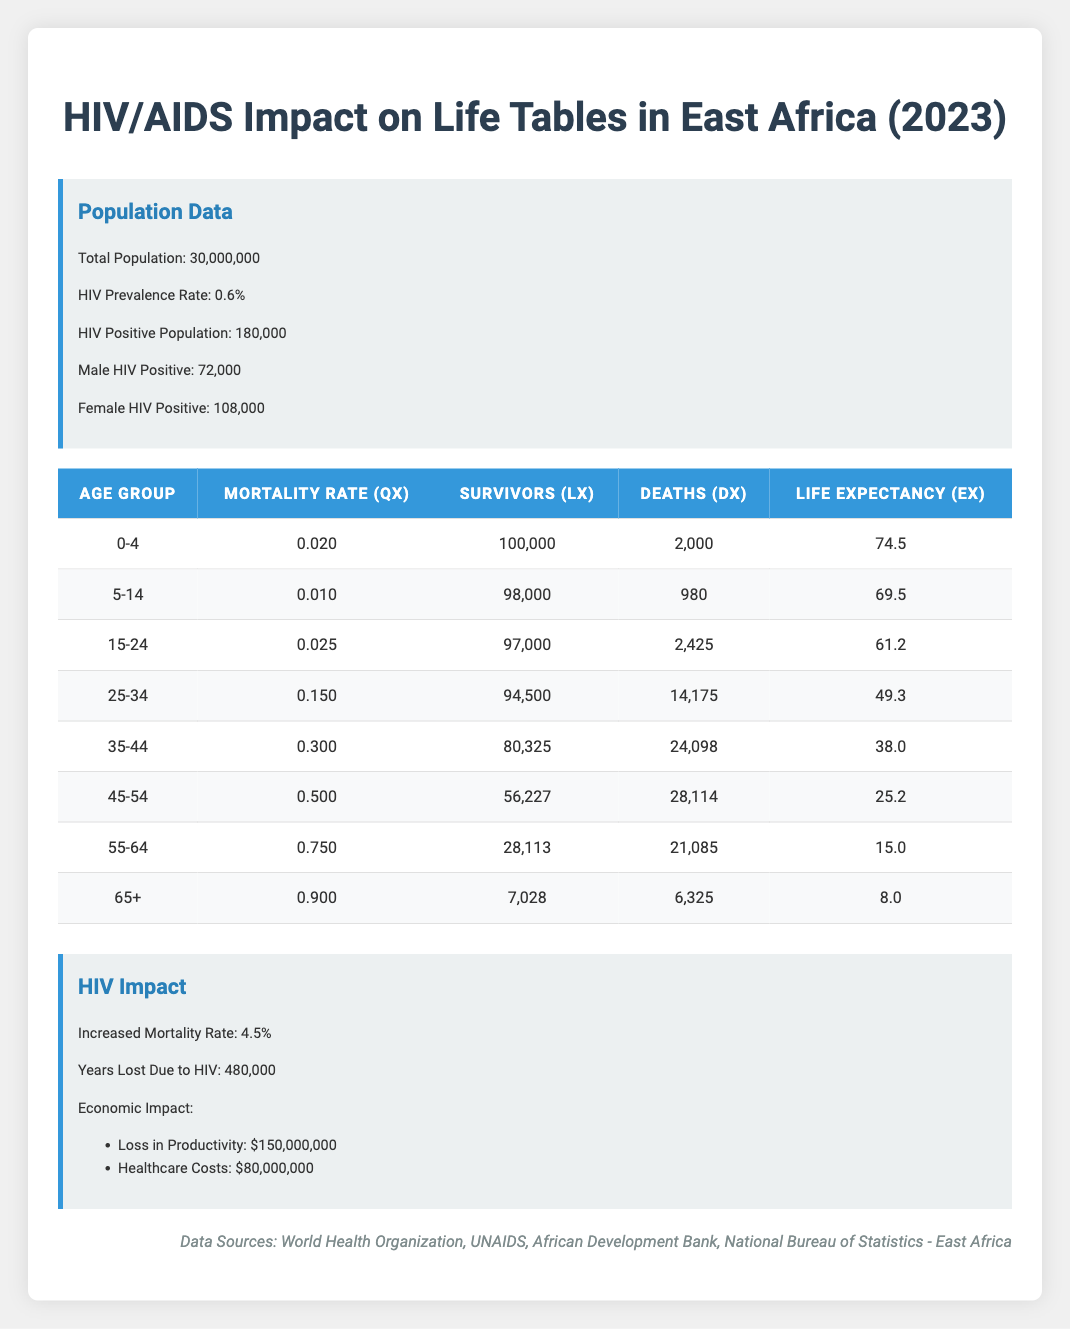What is the total population in East Africa according to the table? The table states the total population is listed directly under the population data section. It indicates that there are 30,000,000 people in East Africa.
Answer: 30,000,000 What is the life expectancy for the age group 25-34? In the table, under the age group of 25-34, the life expectancy (ex) is presented, which is noted to be 49.3 years.
Answer: 49.3 How many deaths are recorded for the age group 45-54? According to the table under the age group 45-54, the number of deaths (dx) is given as 28,114.
Answer: 28,114 Is the mortality rate for the age group 0-4 higher than that for the age group 5-14? The mortality rate (qx) for age group 0-4 is 0.020 while for age group 5-14 it is 0.010. Since 0.020 is greater than 0.010, the answer is yes, it is higher.
Answer: Yes What is the total number of HIV positive individuals in the population? The total number of HIV positive individuals can be directly found under the population data section, which shows that there are 180,000 people that are HIV positive.
Answer: 180,000 Calculate the average life expectancy of the age groups 0-4 and 5-14. To find the average life expectancy of the age groups 0-4 and 5-14, I take the sum of their life expectancies (74.5 and 69.5) and divide by 2. (74.5 + 69.5) / 2 = 72.0 years.
Answer: 72.0 Which age group has the highest number of deaths? By reviewing the deaths (dx) across all age groups, the highest number recorded is 28,114 for the age group 45-54. This indicates that this age group has the highest death count in the provided data.
Answer: 45-54 What is the total loss in productivity due to HIV/AIDS according to the economic impact data? The economic impact section of the table indicates that the loss in productivity is specified as 150,000,000. This figure reflects the direct financial ramifications stemming from HIV/AIDS according to the data presented.
Answer: 150,000,000 If the increase in mortality rate is 4.5%, is the mortality rate highest for the age group 65+? The mortality rate for the age group 65+ is listed as 0.90, which is indeed higher than any other rate listed for the other age groups in the table, confirming that 0.90 equates to an increase of 90%.
Answer: Yes 